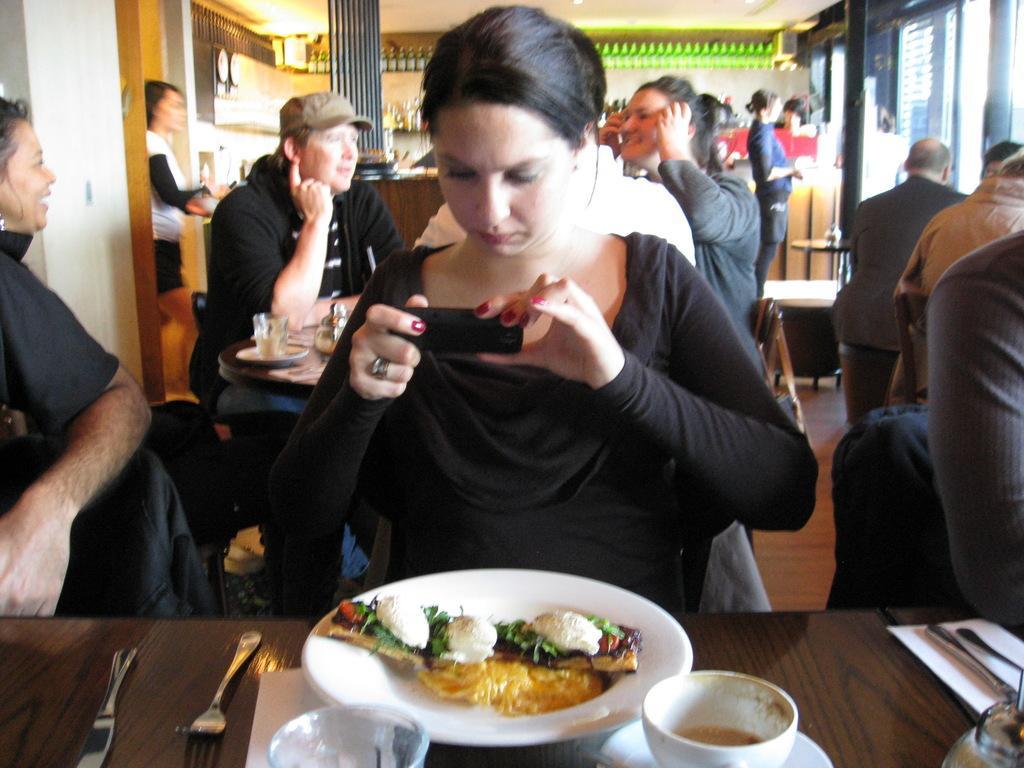Could you give a brief overview of what you see in this image? In the picture I can see a few persons sitting on the chairs. There is a woman in the middle of the image and she is capturing an image with a mobile phone. In the foreground I can see the wooden table. I can see a plate, forks, butter knives and bowls are kept on the table. In the background, I can see two persons and looks like they are having a conversation. 